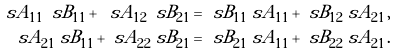Convert formula to latex. <formula><loc_0><loc_0><loc_500><loc_500>\ s A _ { 1 1 } \ s B _ { 1 1 } + \ s A _ { 1 2 } \ s B _ { 2 1 } & = \ s B _ { 1 1 } \ s A _ { 1 1 } + \ s B _ { 1 2 } \ s A _ { 2 1 } \, , \\ \ s A _ { 2 1 } \ s B _ { 1 1 } + \ s A _ { 2 2 } \ s B _ { 2 1 } & = \ s B _ { 2 1 } \ s A _ { 1 1 } + \ s B _ { 2 2 } \ s A _ { 2 1 } \, .</formula> 